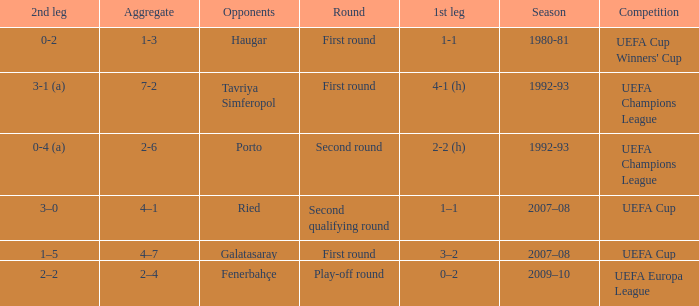What is the total number of round where opponents is haugar 1.0. 